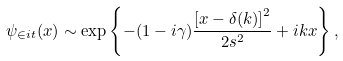<formula> <loc_0><loc_0><loc_500><loc_500>\psi _ { \in i t } ( x ) \sim \exp \left \{ - ( 1 - i \gamma ) \frac { \left [ x - \delta ( k ) \right ] ^ { 2 } } { 2 s ^ { 2 } } + i k x \right \} ,</formula> 